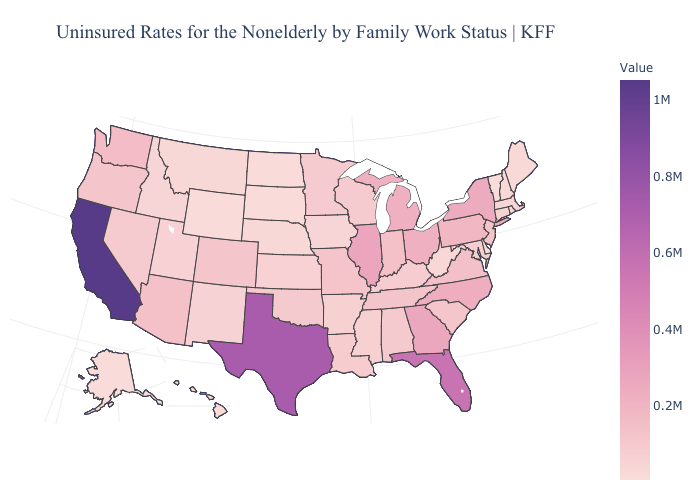Does California have the highest value in the USA?
Give a very brief answer. Yes. Does Montana have the lowest value in the USA?
Concise answer only. No. Does South Dakota have a lower value than Illinois?
Concise answer only. Yes. Which states have the highest value in the USA?
Write a very short answer. California. 